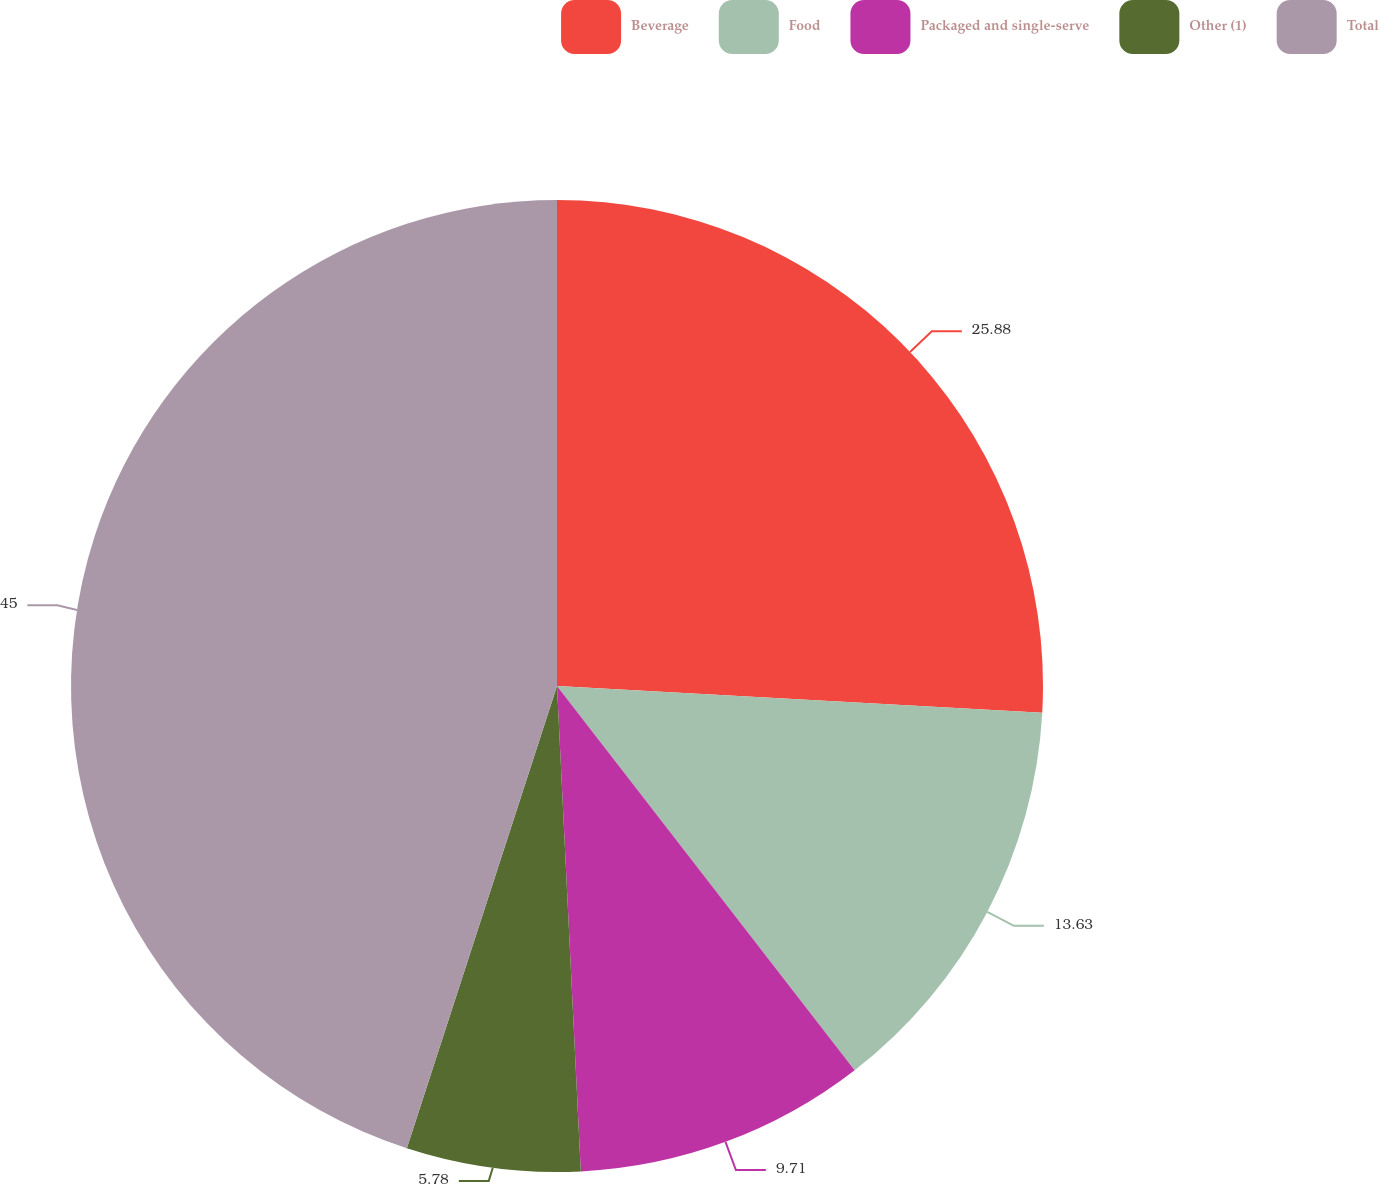<chart> <loc_0><loc_0><loc_500><loc_500><pie_chart><fcel>Beverage<fcel>Food<fcel>Packaged and single-serve<fcel>Other (1)<fcel>Total<nl><fcel>25.88%<fcel>13.63%<fcel>9.71%<fcel>5.78%<fcel>45.0%<nl></chart> 